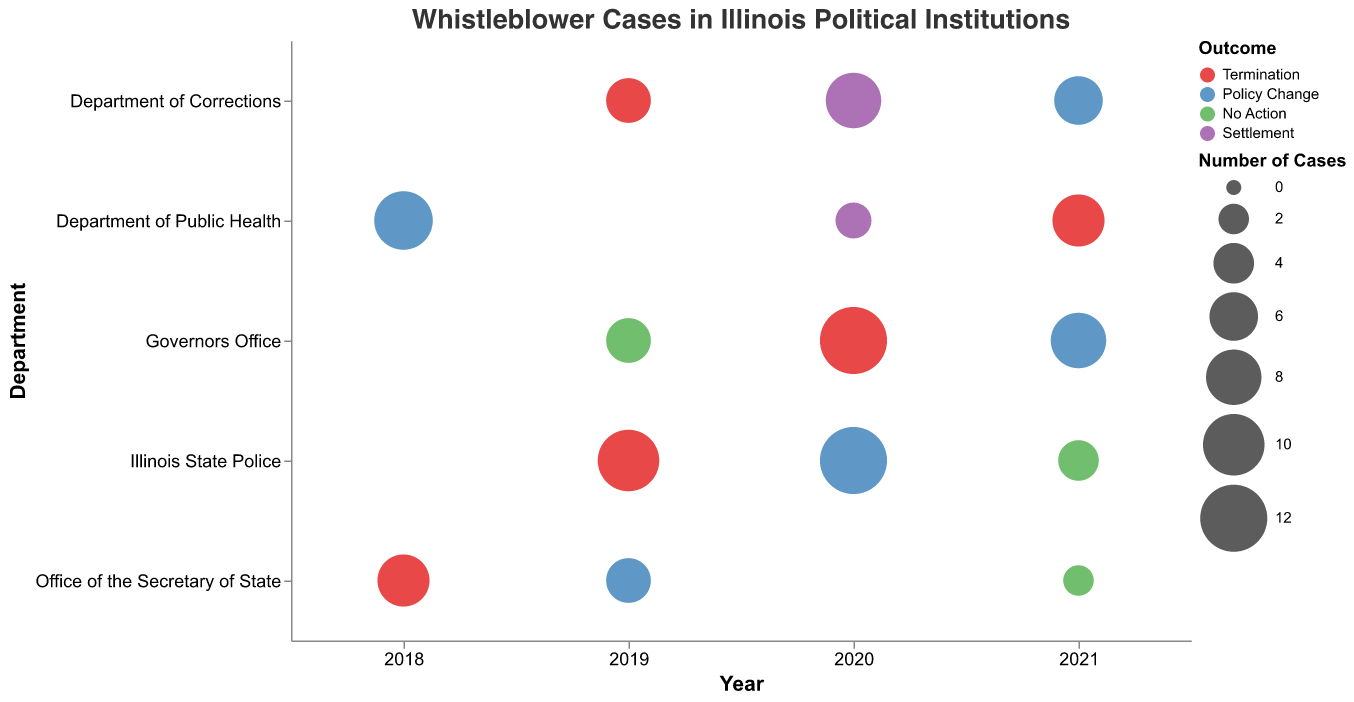What is the title of the figure? The title is usually displayed at the top of the figure. Looking at the figure, the title should be clear and easy to identify.
Answer: Whistleblower Cases in Illinois Political Institutions Which department has the highest number of termination cases in a single year? Look for the largest circles colored in red (Termination) and check their positions along the y-axis for the department. The Governors Office has a circle with 12 cases, the largest for terminations.
Answer: Governors Office How many Policy Change cases were reported in the Illinois State Police in 2020? Find the circle associated with the Illinois State Police on the y-axis for the year 2020 on the x-axis, and look for a blue circle (Policy Change). The tooltip or legend should indicate 12 cases.
Answer: 12 What is the trend in the number of No Action cases over the years? Identify the green circles representing No Action. Count the number of cases in ascending order of years: 2019 (5), 2020 (0), 2021 (6) to understand if they are increasing, decreasing, or stable.
Answer: No Action cases are increasing Which department had the highest number of Termination cases in 2019? Look for red circles in the year 2019 and compare their sizes. The Illinois State Police has the largest circle with 10 cases.
Answer: Illinois State Police Compare the number of Settlement cases in the Department of Corrections and the Department of Public Health in 2020. Which has more? Find purple circles in 2020 for both departments and compare their sizes. Department of Corrections has 8 cases and Department of Public Health has 3 cases.
Answer: Department of Corrections What pattern do you notice in Policy Change cases across different departments? Look for blue circles across different departments and observe their sizes for comparison. Policy Change cases occur in most departments with varying sizes, indicating a spread without dominance by one department.
Answer: Spread across departments How many departments had whistleblower cases with a high severity level? Find all cases marked with "High" severity, and count distinct departments they belong to. Departments with high severity are: Governors Office, Department of Public Health, Illinois State Police, Department of Corrections, Office of the Secretary of State.
Answer: 5 departments What year had the fewest number of total whistleblower cases? Sum the number of cases for each year across all departments and find the year with the smallest total. Summing up the cases: 2018 (12), 2019 (24), 2020 (23), 2021 (27). The year 2018 has the fewest.
Answer: 2018 Which department has the most diverse set of outcomes for whistleblower cases? Identify the department with varied colors (representing different outcomes). The Governors Office has Termination, Policy Change, and No Action, showing the most diverse outcomes.
Answer: Governors Office 